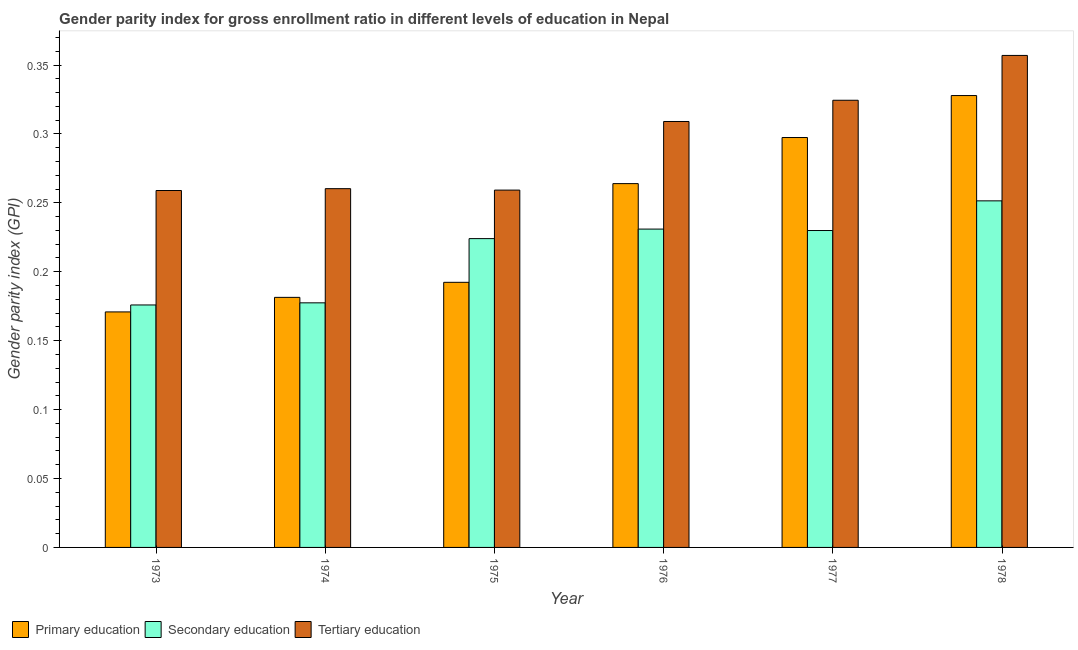How many groups of bars are there?
Make the answer very short. 6. Are the number of bars per tick equal to the number of legend labels?
Your response must be concise. Yes. What is the label of the 6th group of bars from the left?
Give a very brief answer. 1978. What is the gender parity index in primary education in 1976?
Offer a very short reply. 0.26. Across all years, what is the maximum gender parity index in primary education?
Ensure brevity in your answer.  0.33. Across all years, what is the minimum gender parity index in primary education?
Your answer should be very brief. 0.17. In which year was the gender parity index in tertiary education maximum?
Your answer should be compact. 1978. In which year was the gender parity index in primary education minimum?
Offer a terse response. 1973. What is the total gender parity index in secondary education in the graph?
Your response must be concise. 1.29. What is the difference between the gender parity index in primary education in 1974 and that in 1977?
Make the answer very short. -0.12. What is the difference between the gender parity index in primary education in 1975 and the gender parity index in secondary education in 1974?
Your answer should be very brief. 0.01. What is the average gender parity index in primary education per year?
Offer a very short reply. 0.24. In the year 1975, what is the difference between the gender parity index in tertiary education and gender parity index in primary education?
Offer a very short reply. 0. In how many years, is the gender parity index in tertiary education greater than 0.32000000000000006?
Ensure brevity in your answer.  2. What is the ratio of the gender parity index in primary education in 1976 to that in 1978?
Give a very brief answer. 0.81. Is the gender parity index in secondary education in 1975 less than that in 1978?
Your response must be concise. Yes. Is the difference between the gender parity index in tertiary education in 1974 and 1978 greater than the difference between the gender parity index in primary education in 1974 and 1978?
Offer a terse response. No. What is the difference between the highest and the second highest gender parity index in secondary education?
Ensure brevity in your answer.  0.02. What is the difference between the highest and the lowest gender parity index in secondary education?
Offer a very short reply. 0.08. Is the sum of the gender parity index in tertiary education in 1974 and 1977 greater than the maximum gender parity index in secondary education across all years?
Your response must be concise. Yes. What does the 3rd bar from the left in 1974 represents?
Offer a very short reply. Tertiary education. What does the 3rd bar from the right in 1977 represents?
Make the answer very short. Primary education. Is it the case that in every year, the sum of the gender parity index in primary education and gender parity index in secondary education is greater than the gender parity index in tertiary education?
Make the answer very short. Yes. How many bars are there?
Make the answer very short. 18. Are all the bars in the graph horizontal?
Provide a succinct answer. No. Are the values on the major ticks of Y-axis written in scientific E-notation?
Keep it short and to the point. No. Where does the legend appear in the graph?
Ensure brevity in your answer.  Bottom left. How many legend labels are there?
Ensure brevity in your answer.  3. How are the legend labels stacked?
Your answer should be very brief. Horizontal. What is the title of the graph?
Make the answer very short. Gender parity index for gross enrollment ratio in different levels of education in Nepal. What is the label or title of the Y-axis?
Ensure brevity in your answer.  Gender parity index (GPI). What is the Gender parity index (GPI) of Primary education in 1973?
Your answer should be compact. 0.17. What is the Gender parity index (GPI) of Secondary education in 1973?
Make the answer very short. 0.18. What is the Gender parity index (GPI) of Tertiary education in 1973?
Your answer should be compact. 0.26. What is the Gender parity index (GPI) in Primary education in 1974?
Provide a succinct answer. 0.18. What is the Gender parity index (GPI) in Secondary education in 1974?
Offer a terse response. 0.18. What is the Gender parity index (GPI) in Tertiary education in 1974?
Provide a short and direct response. 0.26. What is the Gender parity index (GPI) of Primary education in 1975?
Your response must be concise. 0.19. What is the Gender parity index (GPI) of Secondary education in 1975?
Your answer should be compact. 0.22. What is the Gender parity index (GPI) of Tertiary education in 1975?
Your answer should be very brief. 0.26. What is the Gender parity index (GPI) in Primary education in 1976?
Your response must be concise. 0.26. What is the Gender parity index (GPI) of Secondary education in 1976?
Make the answer very short. 0.23. What is the Gender parity index (GPI) in Tertiary education in 1976?
Ensure brevity in your answer.  0.31. What is the Gender parity index (GPI) of Primary education in 1977?
Provide a short and direct response. 0.3. What is the Gender parity index (GPI) of Secondary education in 1977?
Offer a very short reply. 0.23. What is the Gender parity index (GPI) in Tertiary education in 1977?
Your response must be concise. 0.32. What is the Gender parity index (GPI) of Primary education in 1978?
Your response must be concise. 0.33. What is the Gender parity index (GPI) in Secondary education in 1978?
Keep it short and to the point. 0.25. What is the Gender parity index (GPI) of Tertiary education in 1978?
Your response must be concise. 0.36. Across all years, what is the maximum Gender parity index (GPI) of Primary education?
Offer a very short reply. 0.33. Across all years, what is the maximum Gender parity index (GPI) of Secondary education?
Ensure brevity in your answer.  0.25. Across all years, what is the maximum Gender parity index (GPI) of Tertiary education?
Give a very brief answer. 0.36. Across all years, what is the minimum Gender parity index (GPI) in Primary education?
Offer a very short reply. 0.17. Across all years, what is the minimum Gender parity index (GPI) in Secondary education?
Your response must be concise. 0.18. Across all years, what is the minimum Gender parity index (GPI) in Tertiary education?
Your answer should be very brief. 0.26. What is the total Gender parity index (GPI) of Primary education in the graph?
Your answer should be very brief. 1.43. What is the total Gender parity index (GPI) of Secondary education in the graph?
Offer a terse response. 1.29. What is the total Gender parity index (GPI) of Tertiary education in the graph?
Ensure brevity in your answer.  1.77. What is the difference between the Gender parity index (GPI) of Primary education in 1973 and that in 1974?
Your answer should be compact. -0.01. What is the difference between the Gender parity index (GPI) in Secondary education in 1973 and that in 1974?
Offer a very short reply. -0. What is the difference between the Gender parity index (GPI) of Tertiary education in 1973 and that in 1974?
Make the answer very short. -0. What is the difference between the Gender parity index (GPI) in Primary education in 1973 and that in 1975?
Provide a short and direct response. -0.02. What is the difference between the Gender parity index (GPI) in Secondary education in 1973 and that in 1975?
Give a very brief answer. -0.05. What is the difference between the Gender parity index (GPI) of Tertiary education in 1973 and that in 1975?
Provide a succinct answer. -0. What is the difference between the Gender parity index (GPI) in Primary education in 1973 and that in 1976?
Your answer should be very brief. -0.09. What is the difference between the Gender parity index (GPI) in Secondary education in 1973 and that in 1976?
Your answer should be compact. -0.06. What is the difference between the Gender parity index (GPI) in Tertiary education in 1973 and that in 1976?
Make the answer very short. -0.05. What is the difference between the Gender parity index (GPI) in Primary education in 1973 and that in 1977?
Make the answer very short. -0.13. What is the difference between the Gender parity index (GPI) of Secondary education in 1973 and that in 1977?
Keep it short and to the point. -0.05. What is the difference between the Gender parity index (GPI) of Tertiary education in 1973 and that in 1977?
Give a very brief answer. -0.07. What is the difference between the Gender parity index (GPI) of Primary education in 1973 and that in 1978?
Your response must be concise. -0.16. What is the difference between the Gender parity index (GPI) in Secondary education in 1973 and that in 1978?
Provide a succinct answer. -0.08. What is the difference between the Gender parity index (GPI) in Tertiary education in 1973 and that in 1978?
Provide a short and direct response. -0.1. What is the difference between the Gender parity index (GPI) in Primary education in 1974 and that in 1975?
Offer a very short reply. -0.01. What is the difference between the Gender parity index (GPI) of Secondary education in 1974 and that in 1975?
Ensure brevity in your answer.  -0.05. What is the difference between the Gender parity index (GPI) of Primary education in 1974 and that in 1976?
Offer a terse response. -0.08. What is the difference between the Gender parity index (GPI) in Secondary education in 1974 and that in 1976?
Your answer should be very brief. -0.05. What is the difference between the Gender parity index (GPI) in Tertiary education in 1974 and that in 1976?
Your response must be concise. -0.05. What is the difference between the Gender parity index (GPI) in Primary education in 1974 and that in 1977?
Provide a succinct answer. -0.12. What is the difference between the Gender parity index (GPI) of Secondary education in 1974 and that in 1977?
Offer a terse response. -0.05. What is the difference between the Gender parity index (GPI) in Tertiary education in 1974 and that in 1977?
Ensure brevity in your answer.  -0.06. What is the difference between the Gender parity index (GPI) in Primary education in 1974 and that in 1978?
Offer a very short reply. -0.15. What is the difference between the Gender parity index (GPI) in Secondary education in 1974 and that in 1978?
Ensure brevity in your answer.  -0.07. What is the difference between the Gender parity index (GPI) in Tertiary education in 1974 and that in 1978?
Offer a very short reply. -0.1. What is the difference between the Gender parity index (GPI) of Primary education in 1975 and that in 1976?
Your answer should be compact. -0.07. What is the difference between the Gender parity index (GPI) in Secondary education in 1975 and that in 1976?
Ensure brevity in your answer.  -0.01. What is the difference between the Gender parity index (GPI) of Tertiary education in 1975 and that in 1976?
Your response must be concise. -0.05. What is the difference between the Gender parity index (GPI) of Primary education in 1975 and that in 1977?
Offer a terse response. -0.1. What is the difference between the Gender parity index (GPI) in Secondary education in 1975 and that in 1977?
Your answer should be compact. -0.01. What is the difference between the Gender parity index (GPI) of Tertiary education in 1975 and that in 1977?
Provide a succinct answer. -0.07. What is the difference between the Gender parity index (GPI) in Primary education in 1975 and that in 1978?
Your response must be concise. -0.14. What is the difference between the Gender parity index (GPI) in Secondary education in 1975 and that in 1978?
Offer a very short reply. -0.03. What is the difference between the Gender parity index (GPI) in Tertiary education in 1975 and that in 1978?
Offer a very short reply. -0.1. What is the difference between the Gender parity index (GPI) of Primary education in 1976 and that in 1977?
Keep it short and to the point. -0.03. What is the difference between the Gender parity index (GPI) in Tertiary education in 1976 and that in 1977?
Offer a very short reply. -0.02. What is the difference between the Gender parity index (GPI) in Primary education in 1976 and that in 1978?
Give a very brief answer. -0.06. What is the difference between the Gender parity index (GPI) in Secondary education in 1976 and that in 1978?
Offer a very short reply. -0.02. What is the difference between the Gender parity index (GPI) in Tertiary education in 1976 and that in 1978?
Provide a short and direct response. -0.05. What is the difference between the Gender parity index (GPI) of Primary education in 1977 and that in 1978?
Provide a succinct answer. -0.03. What is the difference between the Gender parity index (GPI) in Secondary education in 1977 and that in 1978?
Your response must be concise. -0.02. What is the difference between the Gender parity index (GPI) in Tertiary education in 1977 and that in 1978?
Make the answer very short. -0.03. What is the difference between the Gender parity index (GPI) in Primary education in 1973 and the Gender parity index (GPI) in Secondary education in 1974?
Your answer should be compact. -0.01. What is the difference between the Gender parity index (GPI) of Primary education in 1973 and the Gender parity index (GPI) of Tertiary education in 1974?
Your answer should be very brief. -0.09. What is the difference between the Gender parity index (GPI) in Secondary education in 1973 and the Gender parity index (GPI) in Tertiary education in 1974?
Your answer should be compact. -0.08. What is the difference between the Gender parity index (GPI) of Primary education in 1973 and the Gender parity index (GPI) of Secondary education in 1975?
Give a very brief answer. -0.05. What is the difference between the Gender parity index (GPI) of Primary education in 1973 and the Gender parity index (GPI) of Tertiary education in 1975?
Your response must be concise. -0.09. What is the difference between the Gender parity index (GPI) of Secondary education in 1973 and the Gender parity index (GPI) of Tertiary education in 1975?
Give a very brief answer. -0.08. What is the difference between the Gender parity index (GPI) of Primary education in 1973 and the Gender parity index (GPI) of Secondary education in 1976?
Your answer should be very brief. -0.06. What is the difference between the Gender parity index (GPI) in Primary education in 1973 and the Gender parity index (GPI) in Tertiary education in 1976?
Your answer should be very brief. -0.14. What is the difference between the Gender parity index (GPI) of Secondary education in 1973 and the Gender parity index (GPI) of Tertiary education in 1976?
Provide a short and direct response. -0.13. What is the difference between the Gender parity index (GPI) in Primary education in 1973 and the Gender parity index (GPI) in Secondary education in 1977?
Ensure brevity in your answer.  -0.06. What is the difference between the Gender parity index (GPI) of Primary education in 1973 and the Gender parity index (GPI) of Tertiary education in 1977?
Your response must be concise. -0.15. What is the difference between the Gender parity index (GPI) of Secondary education in 1973 and the Gender parity index (GPI) of Tertiary education in 1977?
Keep it short and to the point. -0.15. What is the difference between the Gender parity index (GPI) in Primary education in 1973 and the Gender parity index (GPI) in Secondary education in 1978?
Your response must be concise. -0.08. What is the difference between the Gender parity index (GPI) in Primary education in 1973 and the Gender parity index (GPI) in Tertiary education in 1978?
Offer a terse response. -0.19. What is the difference between the Gender parity index (GPI) in Secondary education in 1973 and the Gender parity index (GPI) in Tertiary education in 1978?
Your answer should be compact. -0.18. What is the difference between the Gender parity index (GPI) in Primary education in 1974 and the Gender parity index (GPI) in Secondary education in 1975?
Offer a terse response. -0.04. What is the difference between the Gender parity index (GPI) in Primary education in 1974 and the Gender parity index (GPI) in Tertiary education in 1975?
Make the answer very short. -0.08. What is the difference between the Gender parity index (GPI) in Secondary education in 1974 and the Gender parity index (GPI) in Tertiary education in 1975?
Your answer should be very brief. -0.08. What is the difference between the Gender parity index (GPI) of Primary education in 1974 and the Gender parity index (GPI) of Secondary education in 1976?
Your response must be concise. -0.05. What is the difference between the Gender parity index (GPI) in Primary education in 1974 and the Gender parity index (GPI) in Tertiary education in 1976?
Your response must be concise. -0.13. What is the difference between the Gender parity index (GPI) in Secondary education in 1974 and the Gender parity index (GPI) in Tertiary education in 1976?
Ensure brevity in your answer.  -0.13. What is the difference between the Gender parity index (GPI) of Primary education in 1974 and the Gender parity index (GPI) of Secondary education in 1977?
Your answer should be compact. -0.05. What is the difference between the Gender parity index (GPI) of Primary education in 1974 and the Gender parity index (GPI) of Tertiary education in 1977?
Keep it short and to the point. -0.14. What is the difference between the Gender parity index (GPI) of Secondary education in 1974 and the Gender parity index (GPI) of Tertiary education in 1977?
Give a very brief answer. -0.15. What is the difference between the Gender parity index (GPI) of Primary education in 1974 and the Gender parity index (GPI) of Secondary education in 1978?
Your answer should be very brief. -0.07. What is the difference between the Gender parity index (GPI) of Primary education in 1974 and the Gender parity index (GPI) of Tertiary education in 1978?
Offer a very short reply. -0.18. What is the difference between the Gender parity index (GPI) in Secondary education in 1974 and the Gender parity index (GPI) in Tertiary education in 1978?
Your answer should be compact. -0.18. What is the difference between the Gender parity index (GPI) in Primary education in 1975 and the Gender parity index (GPI) in Secondary education in 1976?
Provide a short and direct response. -0.04. What is the difference between the Gender parity index (GPI) in Primary education in 1975 and the Gender parity index (GPI) in Tertiary education in 1976?
Ensure brevity in your answer.  -0.12. What is the difference between the Gender parity index (GPI) of Secondary education in 1975 and the Gender parity index (GPI) of Tertiary education in 1976?
Provide a succinct answer. -0.09. What is the difference between the Gender parity index (GPI) of Primary education in 1975 and the Gender parity index (GPI) of Secondary education in 1977?
Your answer should be very brief. -0.04. What is the difference between the Gender parity index (GPI) of Primary education in 1975 and the Gender parity index (GPI) of Tertiary education in 1977?
Offer a very short reply. -0.13. What is the difference between the Gender parity index (GPI) of Secondary education in 1975 and the Gender parity index (GPI) of Tertiary education in 1977?
Offer a very short reply. -0.1. What is the difference between the Gender parity index (GPI) in Primary education in 1975 and the Gender parity index (GPI) in Secondary education in 1978?
Provide a succinct answer. -0.06. What is the difference between the Gender parity index (GPI) in Primary education in 1975 and the Gender parity index (GPI) in Tertiary education in 1978?
Give a very brief answer. -0.16. What is the difference between the Gender parity index (GPI) of Secondary education in 1975 and the Gender parity index (GPI) of Tertiary education in 1978?
Ensure brevity in your answer.  -0.13. What is the difference between the Gender parity index (GPI) in Primary education in 1976 and the Gender parity index (GPI) in Secondary education in 1977?
Provide a short and direct response. 0.03. What is the difference between the Gender parity index (GPI) in Primary education in 1976 and the Gender parity index (GPI) in Tertiary education in 1977?
Make the answer very short. -0.06. What is the difference between the Gender parity index (GPI) of Secondary education in 1976 and the Gender parity index (GPI) of Tertiary education in 1977?
Ensure brevity in your answer.  -0.09. What is the difference between the Gender parity index (GPI) in Primary education in 1976 and the Gender parity index (GPI) in Secondary education in 1978?
Offer a very short reply. 0.01. What is the difference between the Gender parity index (GPI) of Primary education in 1976 and the Gender parity index (GPI) of Tertiary education in 1978?
Offer a terse response. -0.09. What is the difference between the Gender parity index (GPI) of Secondary education in 1976 and the Gender parity index (GPI) of Tertiary education in 1978?
Keep it short and to the point. -0.13. What is the difference between the Gender parity index (GPI) in Primary education in 1977 and the Gender parity index (GPI) in Secondary education in 1978?
Your answer should be compact. 0.05. What is the difference between the Gender parity index (GPI) in Primary education in 1977 and the Gender parity index (GPI) in Tertiary education in 1978?
Your answer should be compact. -0.06. What is the difference between the Gender parity index (GPI) of Secondary education in 1977 and the Gender parity index (GPI) of Tertiary education in 1978?
Offer a terse response. -0.13. What is the average Gender parity index (GPI) in Primary education per year?
Make the answer very short. 0.24. What is the average Gender parity index (GPI) of Secondary education per year?
Your answer should be very brief. 0.21. What is the average Gender parity index (GPI) of Tertiary education per year?
Offer a terse response. 0.29. In the year 1973, what is the difference between the Gender parity index (GPI) of Primary education and Gender parity index (GPI) of Secondary education?
Offer a terse response. -0.01. In the year 1973, what is the difference between the Gender parity index (GPI) of Primary education and Gender parity index (GPI) of Tertiary education?
Your answer should be very brief. -0.09. In the year 1973, what is the difference between the Gender parity index (GPI) in Secondary education and Gender parity index (GPI) in Tertiary education?
Ensure brevity in your answer.  -0.08. In the year 1974, what is the difference between the Gender parity index (GPI) in Primary education and Gender parity index (GPI) in Secondary education?
Ensure brevity in your answer.  0. In the year 1974, what is the difference between the Gender parity index (GPI) of Primary education and Gender parity index (GPI) of Tertiary education?
Offer a very short reply. -0.08. In the year 1974, what is the difference between the Gender parity index (GPI) of Secondary education and Gender parity index (GPI) of Tertiary education?
Your answer should be very brief. -0.08. In the year 1975, what is the difference between the Gender parity index (GPI) in Primary education and Gender parity index (GPI) in Secondary education?
Offer a very short reply. -0.03. In the year 1975, what is the difference between the Gender parity index (GPI) of Primary education and Gender parity index (GPI) of Tertiary education?
Give a very brief answer. -0.07. In the year 1975, what is the difference between the Gender parity index (GPI) of Secondary education and Gender parity index (GPI) of Tertiary education?
Offer a terse response. -0.04. In the year 1976, what is the difference between the Gender parity index (GPI) in Primary education and Gender parity index (GPI) in Secondary education?
Ensure brevity in your answer.  0.03. In the year 1976, what is the difference between the Gender parity index (GPI) in Primary education and Gender parity index (GPI) in Tertiary education?
Your response must be concise. -0.05. In the year 1976, what is the difference between the Gender parity index (GPI) of Secondary education and Gender parity index (GPI) of Tertiary education?
Your response must be concise. -0.08. In the year 1977, what is the difference between the Gender parity index (GPI) of Primary education and Gender parity index (GPI) of Secondary education?
Give a very brief answer. 0.07. In the year 1977, what is the difference between the Gender parity index (GPI) in Primary education and Gender parity index (GPI) in Tertiary education?
Keep it short and to the point. -0.03. In the year 1977, what is the difference between the Gender parity index (GPI) of Secondary education and Gender parity index (GPI) of Tertiary education?
Your response must be concise. -0.09. In the year 1978, what is the difference between the Gender parity index (GPI) of Primary education and Gender parity index (GPI) of Secondary education?
Your answer should be compact. 0.08. In the year 1978, what is the difference between the Gender parity index (GPI) in Primary education and Gender parity index (GPI) in Tertiary education?
Make the answer very short. -0.03. In the year 1978, what is the difference between the Gender parity index (GPI) of Secondary education and Gender parity index (GPI) of Tertiary education?
Offer a very short reply. -0.11. What is the ratio of the Gender parity index (GPI) in Primary education in 1973 to that in 1974?
Your answer should be very brief. 0.94. What is the ratio of the Gender parity index (GPI) of Tertiary education in 1973 to that in 1974?
Offer a very short reply. 0.99. What is the ratio of the Gender parity index (GPI) in Primary education in 1973 to that in 1975?
Provide a short and direct response. 0.89. What is the ratio of the Gender parity index (GPI) in Secondary education in 1973 to that in 1975?
Your answer should be compact. 0.79. What is the ratio of the Gender parity index (GPI) in Tertiary education in 1973 to that in 1975?
Offer a very short reply. 1. What is the ratio of the Gender parity index (GPI) in Primary education in 1973 to that in 1976?
Your response must be concise. 0.65. What is the ratio of the Gender parity index (GPI) in Secondary education in 1973 to that in 1976?
Keep it short and to the point. 0.76. What is the ratio of the Gender parity index (GPI) of Tertiary education in 1973 to that in 1976?
Your answer should be compact. 0.84. What is the ratio of the Gender parity index (GPI) of Primary education in 1973 to that in 1977?
Provide a succinct answer. 0.57. What is the ratio of the Gender parity index (GPI) in Secondary education in 1973 to that in 1977?
Make the answer very short. 0.77. What is the ratio of the Gender parity index (GPI) in Tertiary education in 1973 to that in 1977?
Give a very brief answer. 0.8. What is the ratio of the Gender parity index (GPI) of Primary education in 1973 to that in 1978?
Offer a terse response. 0.52. What is the ratio of the Gender parity index (GPI) of Secondary education in 1973 to that in 1978?
Your answer should be very brief. 0.7. What is the ratio of the Gender parity index (GPI) of Tertiary education in 1973 to that in 1978?
Keep it short and to the point. 0.73. What is the ratio of the Gender parity index (GPI) of Primary education in 1974 to that in 1975?
Make the answer very short. 0.94. What is the ratio of the Gender parity index (GPI) of Secondary education in 1974 to that in 1975?
Keep it short and to the point. 0.79. What is the ratio of the Gender parity index (GPI) in Tertiary education in 1974 to that in 1975?
Offer a terse response. 1. What is the ratio of the Gender parity index (GPI) of Primary education in 1974 to that in 1976?
Ensure brevity in your answer.  0.69. What is the ratio of the Gender parity index (GPI) in Secondary education in 1974 to that in 1976?
Provide a short and direct response. 0.77. What is the ratio of the Gender parity index (GPI) of Tertiary education in 1974 to that in 1976?
Your answer should be very brief. 0.84. What is the ratio of the Gender parity index (GPI) in Primary education in 1974 to that in 1977?
Provide a short and direct response. 0.61. What is the ratio of the Gender parity index (GPI) in Secondary education in 1974 to that in 1977?
Your answer should be compact. 0.77. What is the ratio of the Gender parity index (GPI) of Tertiary education in 1974 to that in 1977?
Offer a terse response. 0.8. What is the ratio of the Gender parity index (GPI) in Primary education in 1974 to that in 1978?
Your answer should be very brief. 0.55. What is the ratio of the Gender parity index (GPI) of Secondary education in 1974 to that in 1978?
Your answer should be very brief. 0.71. What is the ratio of the Gender parity index (GPI) in Tertiary education in 1974 to that in 1978?
Your response must be concise. 0.73. What is the ratio of the Gender parity index (GPI) in Primary education in 1975 to that in 1976?
Keep it short and to the point. 0.73. What is the ratio of the Gender parity index (GPI) of Tertiary education in 1975 to that in 1976?
Offer a very short reply. 0.84. What is the ratio of the Gender parity index (GPI) of Primary education in 1975 to that in 1977?
Your answer should be compact. 0.65. What is the ratio of the Gender parity index (GPI) in Secondary education in 1975 to that in 1977?
Offer a very short reply. 0.97. What is the ratio of the Gender parity index (GPI) of Tertiary education in 1975 to that in 1977?
Give a very brief answer. 0.8. What is the ratio of the Gender parity index (GPI) of Primary education in 1975 to that in 1978?
Give a very brief answer. 0.59. What is the ratio of the Gender parity index (GPI) in Secondary education in 1975 to that in 1978?
Your response must be concise. 0.89. What is the ratio of the Gender parity index (GPI) in Tertiary education in 1975 to that in 1978?
Give a very brief answer. 0.73. What is the ratio of the Gender parity index (GPI) in Primary education in 1976 to that in 1977?
Keep it short and to the point. 0.89. What is the ratio of the Gender parity index (GPI) in Secondary education in 1976 to that in 1977?
Provide a succinct answer. 1. What is the ratio of the Gender parity index (GPI) of Tertiary education in 1976 to that in 1977?
Provide a succinct answer. 0.95. What is the ratio of the Gender parity index (GPI) of Primary education in 1976 to that in 1978?
Make the answer very short. 0.81. What is the ratio of the Gender parity index (GPI) in Secondary education in 1976 to that in 1978?
Your response must be concise. 0.92. What is the ratio of the Gender parity index (GPI) of Tertiary education in 1976 to that in 1978?
Keep it short and to the point. 0.87. What is the ratio of the Gender parity index (GPI) of Primary education in 1977 to that in 1978?
Provide a short and direct response. 0.91. What is the ratio of the Gender parity index (GPI) in Secondary education in 1977 to that in 1978?
Your response must be concise. 0.91. What is the ratio of the Gender parity index (GPI) of Tertiary education in 1977 to that in 1978?
Ensure brevity in your answer.  0.91. What is the difference between the highest and the second highest Gender parity index (GPI) of Primary education?
Keep it short and to the point. 0.03. What is the difference between the highest and the second highest Gender parity index (GPI) in Secondary education?
Your answer should be compact. 0.02. What is the difference between the highest and the second highest Gender parity index (GPI) of Tertiary education?
Make the answer very short. 0.03. What is the difference between the highest and the lowest Gender parity index (GPI) in Primary education?
Provide a succinct answer. 0.16. What is the difference between the highest and the lowest Gender parity index (GPI) of Secondary education?
Provide a succinct answer. 0.08. What is the difference between the highest and the lowest Gender parity index (GPI) of Tertiary education?
Give a very brief answer. 0.1. 